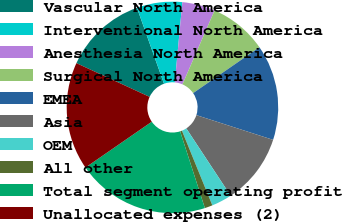<chart> <loc_0><loc_0><loc_500><loc_500><pie_chart><fcel>Vascular North America<fcel>Interventional North America<fcel>Anesthesia North America<fcel>Surgical North America<fcel>EMEA<fcel>Asia<fcel>OEM<fcel>All other<fcel>Total segment operating profit<fcel>Unallocated expenses (2)<nl><fcel>12.68%<fcel>6.94%<fcel>5.03%<fcel>8.85%<fcel>14.59%<fcel>10.76%<fcel>3.12%<fcel>1.2%<fcel>20.33%<fcel>16.5%<nl></chart> 